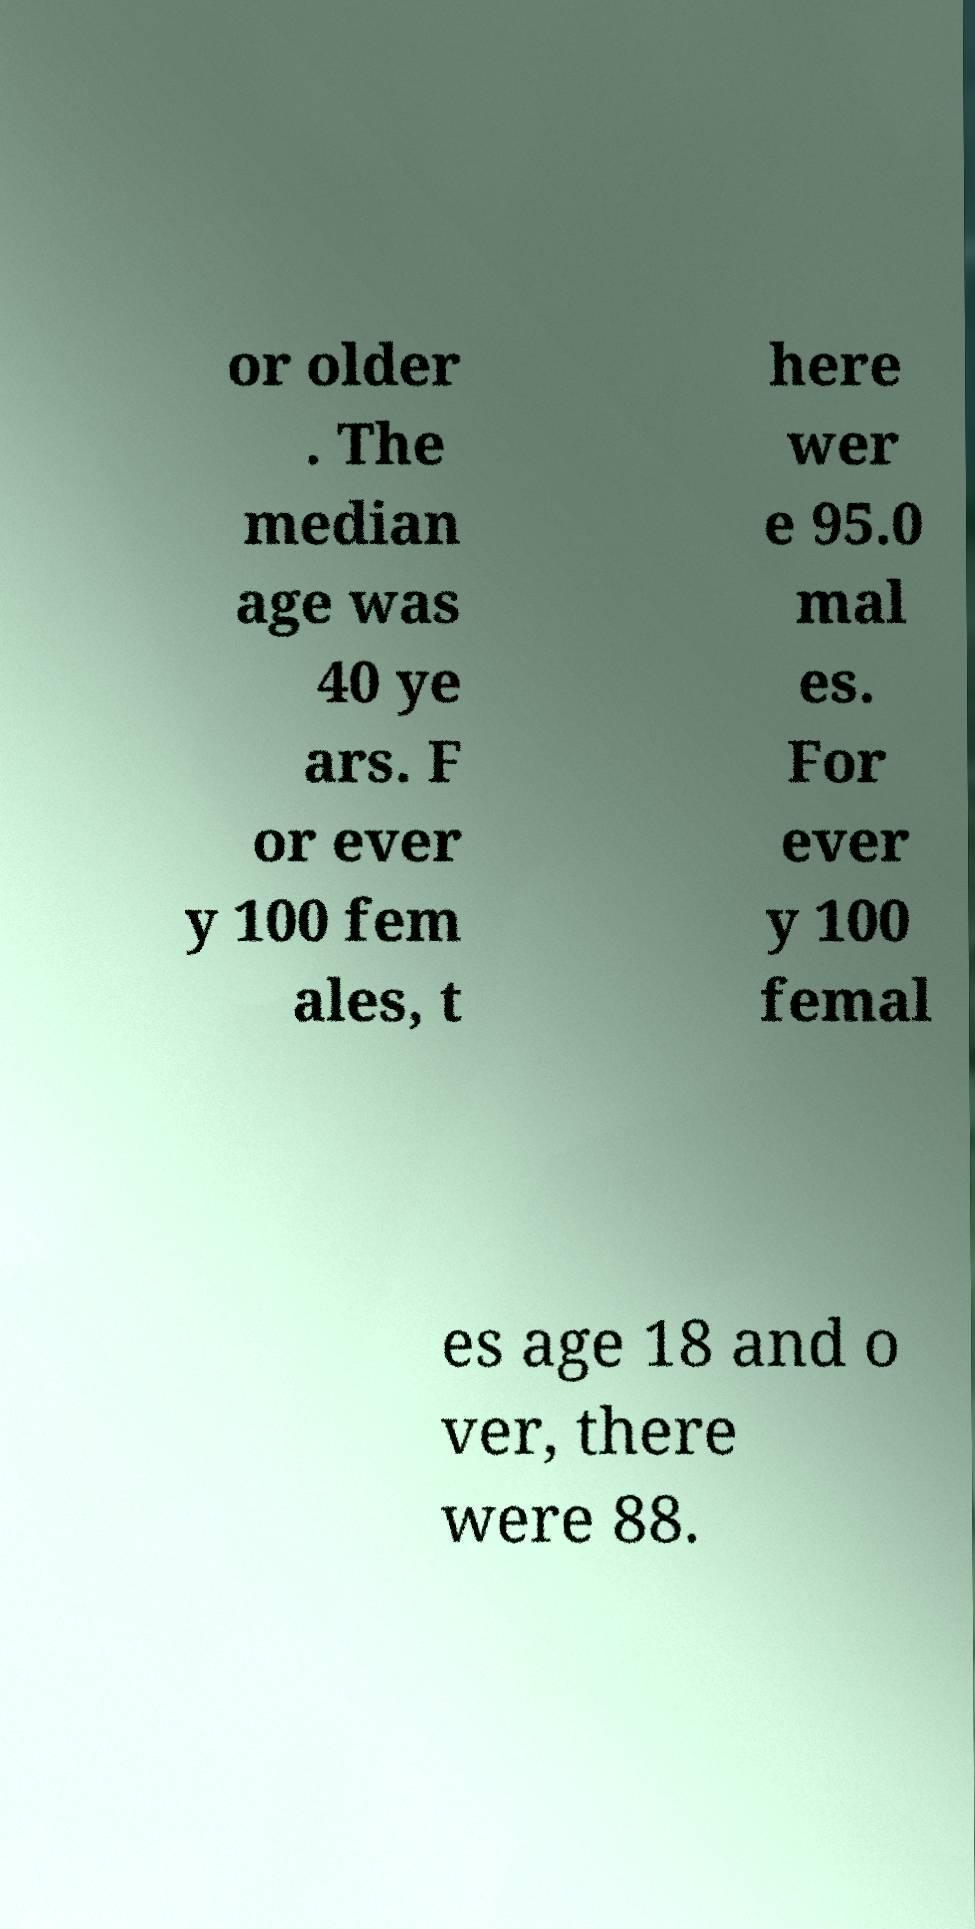I need the written content from this picture converted into text. Can you do that? or older . The median age was 40 ye ars. F or ever y 100 fem ales, t here wer e 95.0 mal es. For ever y 100 femal es age 18 and o ver, there were 88. 